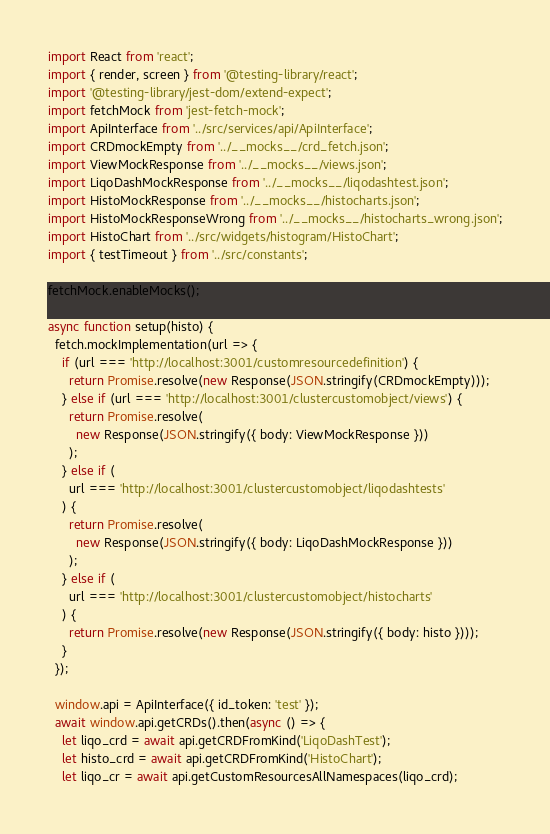Convert code to text. <code><loc_0><loc_0><loc_500><loc_500><_JavaScript_>import React from 'react';
import { render, screen } from '@testing-library/react';
import '@testing-library/jest-dom/extend-expect';
import fetchMock from 'jest-fetch-mock';
import ApiInterface from '../src/services/api/ApiInterface';
import CRDmockEmpty from '../__mocks__/crd_fetch.json';
import ViewMockResponse from '../__mocks__/views.json';
import LiqoDashMockResponse from '../__mocks__/liqodashtest.json';
import HistoMockResponse from '../__mocks__/histocharts.json';
import HistoMockResponseWrong from '../__mocks__/histocharts_wrong.json';
import HistoChart from '../src/widgets/histogram/HistoChart';
import { testTimeout } from '../src/constants';

fetchMock.enableMocks();

async function setup(histo) {
  fetch.mockImplementation(url => {
    if (url === 'http://localhost:3001/customresourcedefinition') {
      return Promise.resolve(new Response(JSON.stringify(CRDmockEmpty)));
    } else if (url === 'http://localhost:3001/clustercustomobject/views') {
      return Promise.resolve(
        new Response(JSON.stringify({ body: ViewMockResponse }))
      );
    } else if (
      url === 'http://localhost:3001/clustercustomobject/liqodashtests'
    ) {
      return Promise.resolve(
        new Response(JSON.stringify({ body: LiqoDashMockResponse }))
      );
    } else if (
      url === 'http://localhost:3001/clustercustomobject/histocharts'
    ) {
      return Promise.resolve(new Response(JSON.stringify({ body: histo })));
    }
  });

  window.api = ApiInterface({ id_token: 'test' });
  await window.api.getCRDs().then(async () => {
    let liqo_crd = await api.getCRDFromKind('LiqoDashTest');
    let histo_crd = await api.getCRDFromKind('HistoChart');
    let liqo_cr = await api.getCustomResourcesAllNamespaces(liqo_crd);</code> 